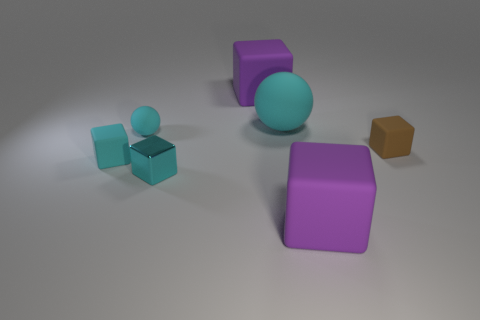Subtract all brown blocks. How many blocks are left? 4 Subtract all small cyan rubber cubes. How many cubes are left? 4 Subtract all green cubes. Subtract all green spheres. How many cubes are left? 5 Add 3 cyan blocks. How many objects exist? 10 Subtract all balls. How many objects are left? 5 Subtract all large purple shiny cylinders. Subtract all metallic cubes. How many objects are left? 6 Add 7 purple matte blocks. How many purple matte blocks are left? 9 Add 2 cyan metallic objects. How many cyan metallic objects exist? 3 Subtract 0 blue cylinders. How many objects are left? 7 